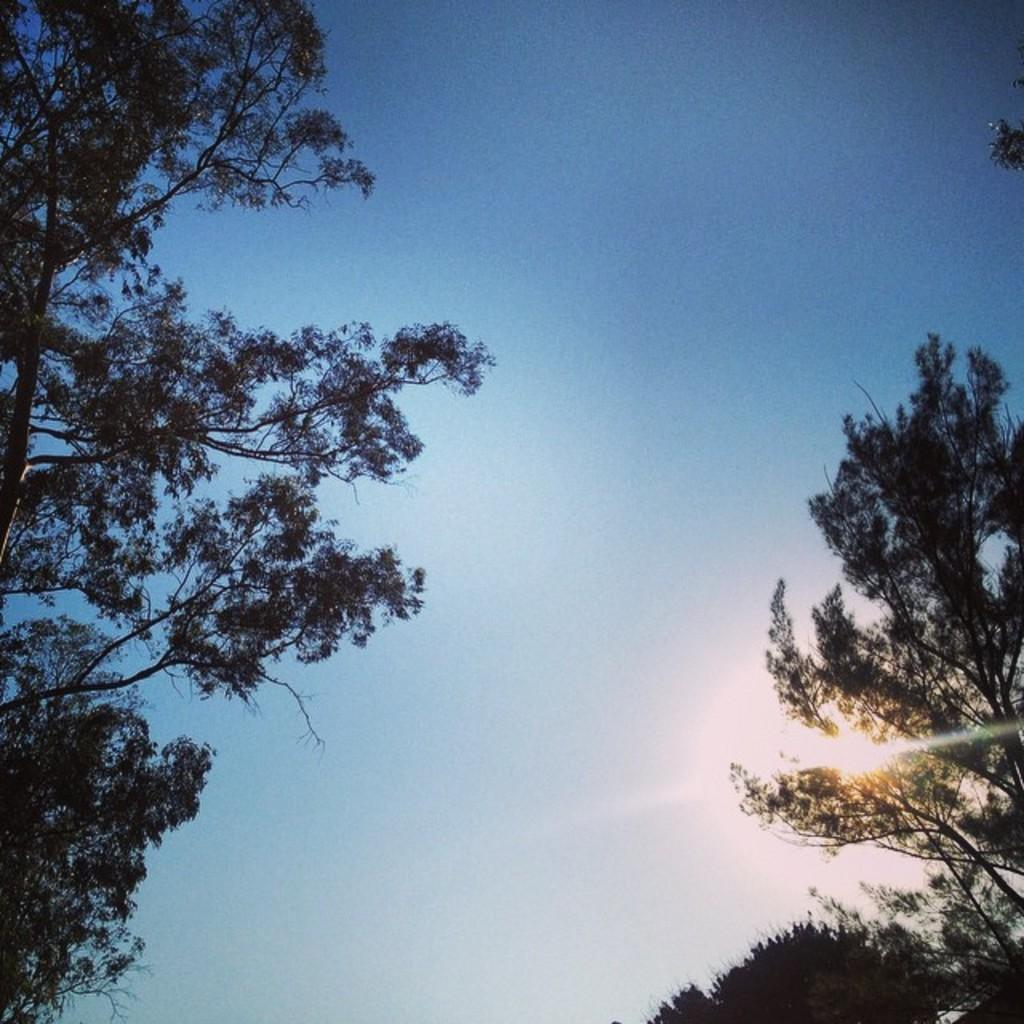What can be seen at the top of the image? The sky is visible in the image. What type of vegetation is on the left side of the image? There are trees on the left side of the image. What type of vegetation is on the right side of the image? There are trees on the right side of the image. What type of sugar is being distributed in the image? There is no sugar or distribution present in the image; it only features the sky and trees. What is the image's stance on hate? The image does not express any stance on hate, as it only contains natural elements like the sky and trees. 